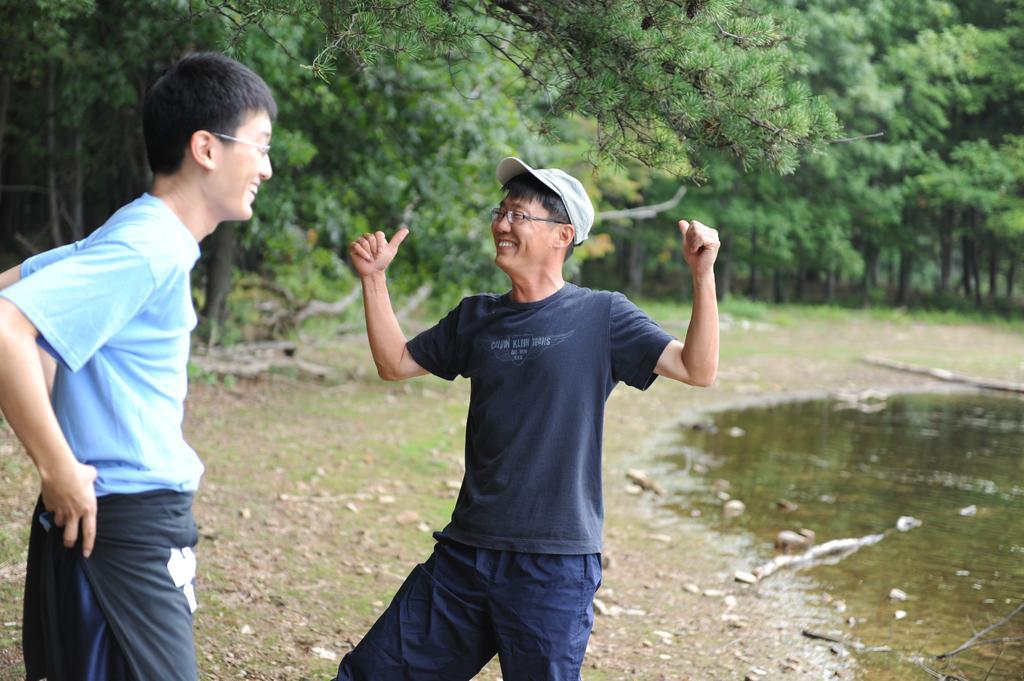How would you summarize this image in a sentence or two? In the picture I can see two persons standing in the left corner and there is water in the right corner and there are trees in the background. 